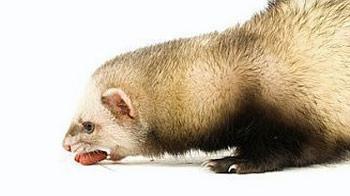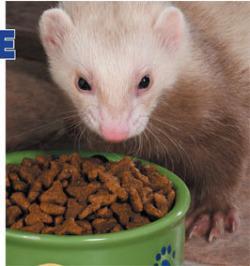The first image is the image on the left, the second image is the image on the right. Analyze the images presented: Is the assertion "The little animal in one image has its mouth wide open with tongue and two lower teeth showing, while a second little animal is eating in the second image." valid? Answer yes or no. No. The first image is the image on the left, the second image is the image on the right. Examine the images to the left and right. Is the description "A ferret with no food in front of it is """"licking its chops"""" with an upturned tongue." accurate? Answer yes or no. No. 